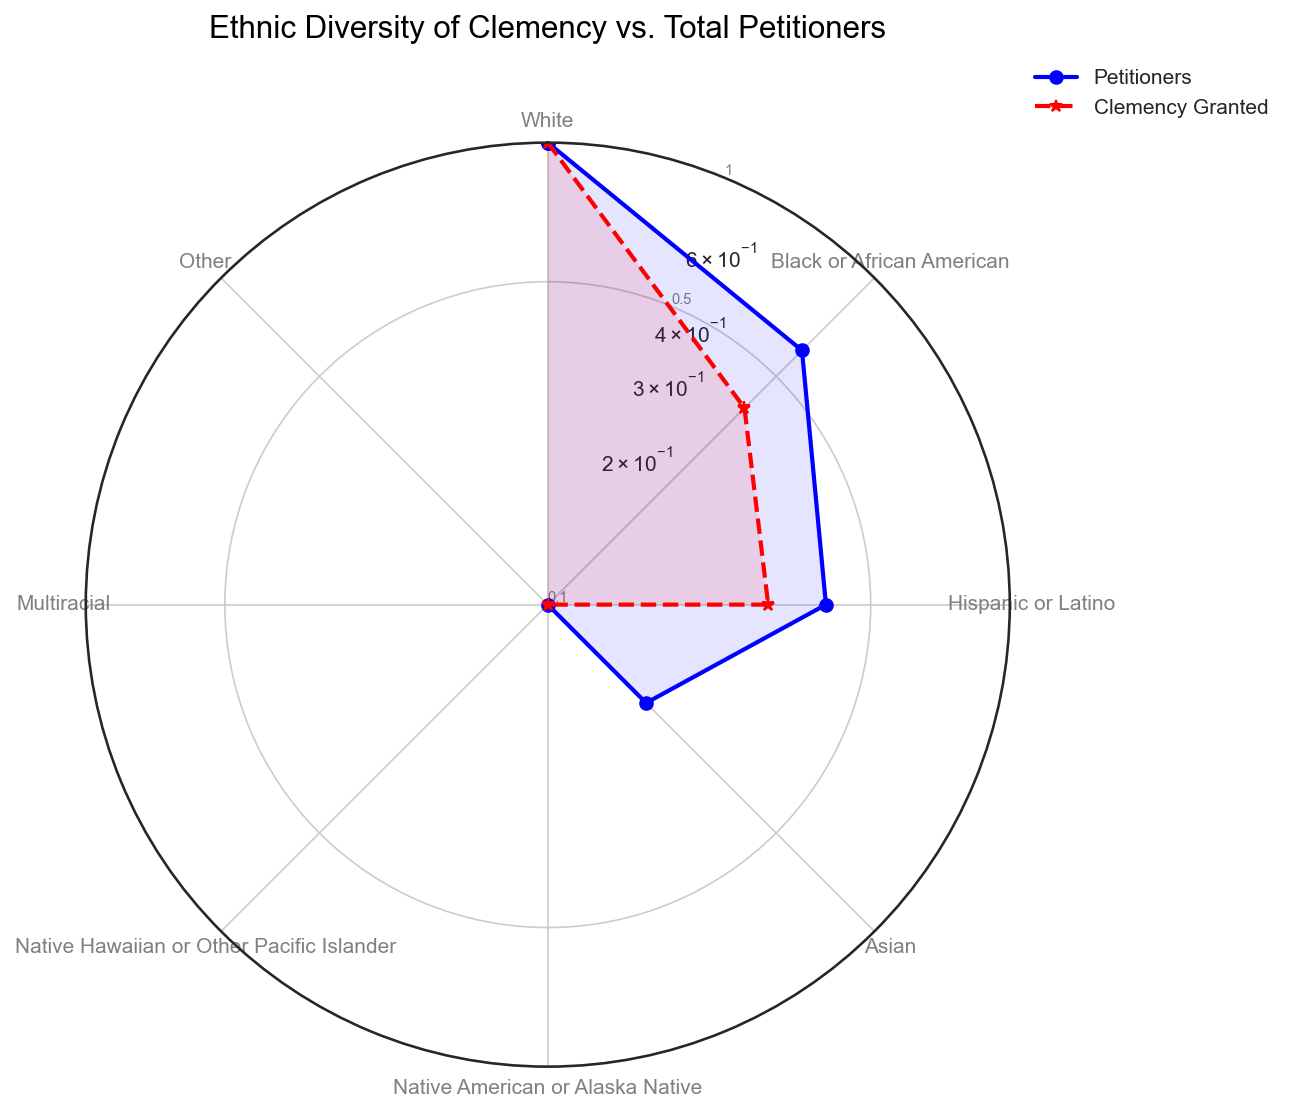What ethnic group has the highest number of petitioners? By observing the blue line representing petitioners, the group with the highest point on the radar chart is "White".
Answer: White Which ethnic group has the smallest percentage of clemency granted? The ethnic group with the smallest red dashed line segment, indicating clemency granted, is "Native Hawaiian or Other Pacific Islander".
Answer: Native Hawaiian or Other Pacific Islander Does the "Black or African American" group have more petitioners or more granted clemency, visually? Comparing the blue and red lines for the "Black or African American" group, the blue line (petitioners) is noticeably higher.
Answer: More petitioners For the "Hispanic or Latino" group, how does the clemency granted compare to the petitioners visually? The "Hispanic or Latino" group has both blue (petitioners) and red (clemency granted) lines, with the blue line being higher, indicating more petitioners than clemency granted.
Answer: More petitioners than clemency granted Which ethnic group shows the largest disparity between petitioners and those granted clemency? The largest visual gap between the blue line (petitioners) and the red line (clemency granted) is for the "White" group.
Answer: White Is the clemency grant rate for the "Asian" group closer to the "Native American or Alaska Native" group or the "Multiracial" group? The clemency rate for the "Asian" group (red line segment) is closer to the "Native American or Alaska Native" group. Both groups are close on the red line.
Answer: Native American or Alaska Native How many ethnic groups show a normalized clemency grant rate of above 0.1? Counting the red line segments above the 0.1 mark, which represents the normalized clemency rate, there are six ethnic groups: "White", "Black or African American", "Hispanic or Latino", "Asian", "Multiracial", and "Other".
Answer: Six Which ethnic group has the most balanced ratio between petitioners and clemency granted visually? The group where the blue line (petitioners) and red line (clemency granted) are closest is the "Multiracial" group.
Answer: Multiracial For the "Native American or Alaska Native" group, does the visual data suggest high or low clemency grants compared to their petitioners? For "Native American or Alaska Native", the red dashed line (clemency granted) is very close to the blue line (petitioners), suggesting a relatively low clemency grant.
Answer: Low clemency grants 